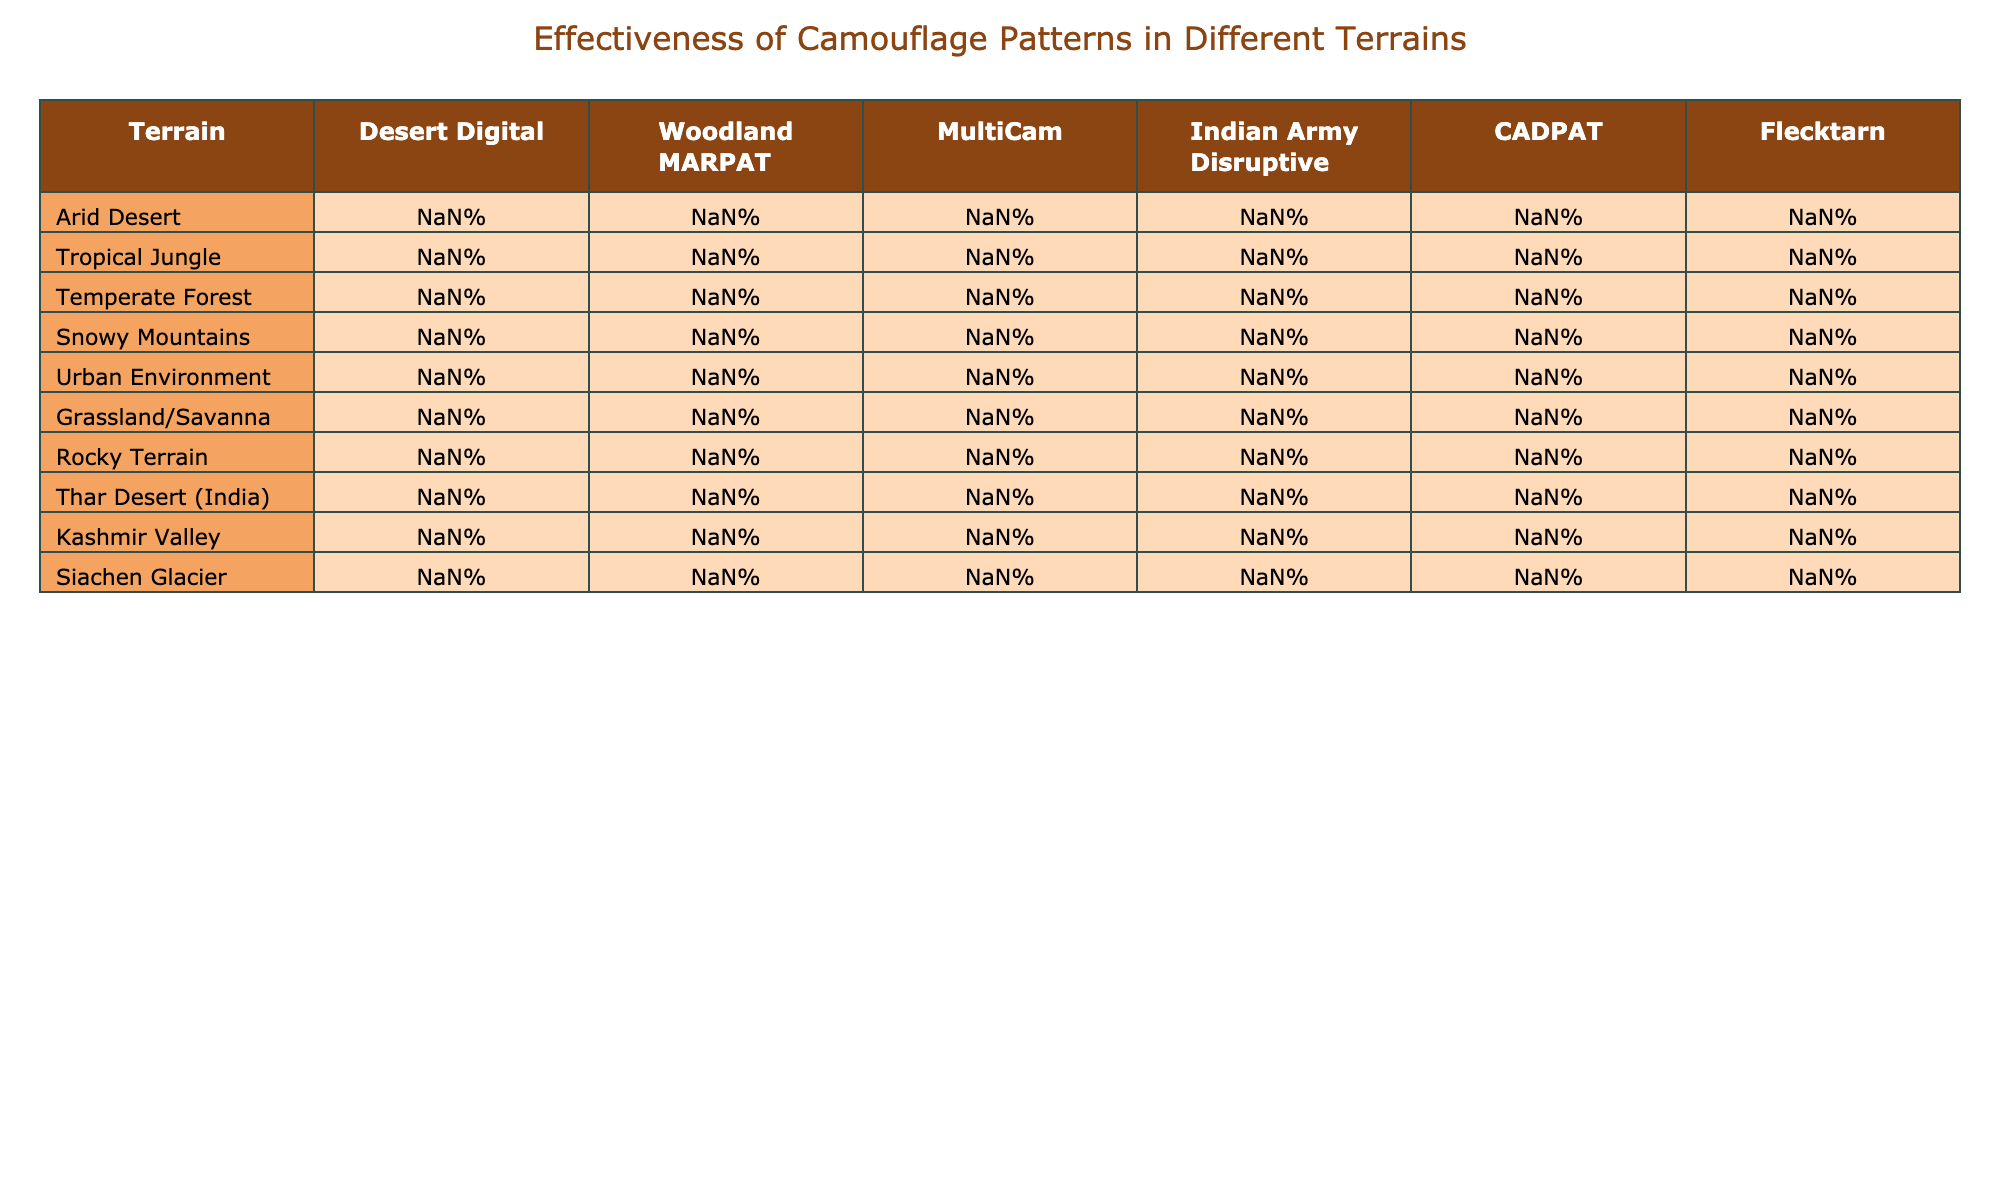What is the effectiveness percentage of MultiCam in a Tropical Jungle? From the table, the effectiveness percentage of MultiCam in a Tropical Jungle is directly listed as 75%
Answer: 75% Which camouflage pattern is most effective in Snowy Mountains? Referring to the Snowy Mountains row, the highest effectiveness percentage is found with CADPAT at 75%
Answer: CADPAT What is the average effectiveness of all camouflage patterns in Urban Environments? The effectiveness percentages in Urban Environment are: Desert Digital (50%), Woodland MARPAT (40%), MultiCam (70%), Indian Army Disruptive (55%), CADPAT (45%), and Flecktarn (60%). Summing these values gives 50 + 40 + 70 + 55 + 45 + 60 = 320. Since there are 6 data points, we divide by 6: 320/6 = approximately 53.33.
Answer: 53.33% Is Indian Army Disruptive more effective than Flecktarn in Grassland/Savanna? In the Grassland/Savanna row, Indian Army Disruptive has an effectiveness of 80%, while Flecktarn has 75%. Thus, Indian Army Disruptive is more effective than Flecktarn in this terrain
Answer: Yes Which camouflage pattern has the lowest effectiveness in the Thar Desert (India)? Looking at the Thar Desert (India) row, the lowest effectiveness percentage is for Woodland MARPAT at 30%.
Answer: Woodland MARPAT What is the difference in effectiveness between MultiCam and Indian Army Disruptive in Arctic Desert? In the Arid Desert row, MultiCam has 85% effectiveness while Indian Army Disruptive has 70%. The difference is calculated as 85 - 70 = 15.
Answer: 15% Which terrain shows the greatest effectiveness for Desert Digital? Checking the effectiveness values for Desert Digital across all terrains, the Arid Desert row shows the highest effectiveness of 95%.
Answer: Arid Desert Is the effectiveness of Woodland MARPAT in Temperate Forest greater than its effectiveness in Tropical Jungle? In Temperate Forest, Woodland MARPAT’s effectiveness is 85%, whereas in Tropical Jungle, it is 90%. Hence, Woodland MARPAT is less effective in Temperate Forest than in Tropical Jungle.
Answer: No What percentage effectiveness does Flecktarn have in Kashmir Valley? From the Kashmir Valley row, Flecktarn has an effectiveness percentage of 65%.
Answer: 65% 